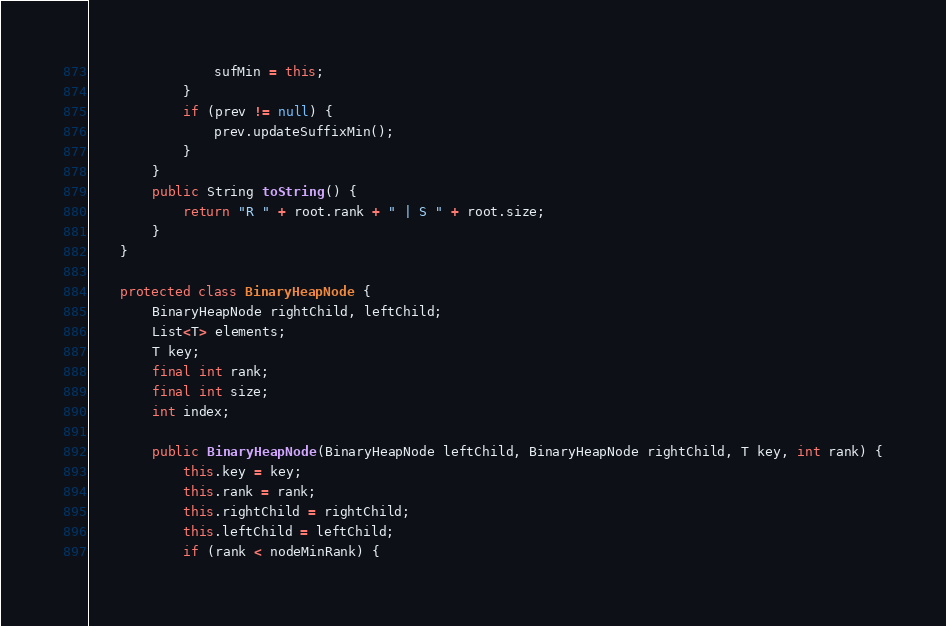<code> <loc_0><loc_0><loc_500><loc_500><_Java_>                sufMin = this;
            }
            if (prev != null) {
                prev.updateSuffixMin();
            } 
        }
        public String toString() {
        	return "R " + root.rank + " | S " + root.size;
        }
    }

    protected class BinaryHeapNode {
        BinaryHeapNode rightChild, leftChild;
        List<T> elements;
        T key;
        final int rank;
        final int size;
        int index;

        public BinaryHeapNode(BinaryHeapNode leftChild, BinaryHeapNode rightChild, T key, int rank) {
            this.key = key;
            this.rank = rank;
            this.rightChild = rightChild;
            this.leftChild = leftChild;
            if (rank < nodeMinRank) {</code> 